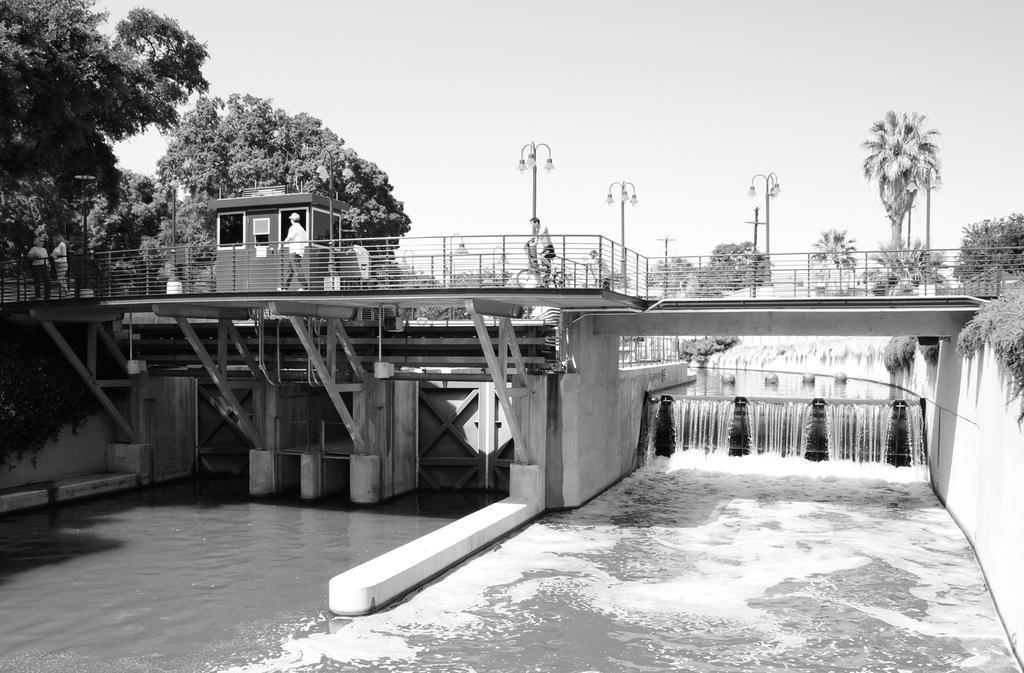Please provide a concise description of this image. This is a black and white picture. In the background we can see the sky and the trees. In this picture we can see a bridge and on the bridge we can see a shelter, people, a man is riding a bicycle. We can see the railings, light poles and other poles. We can see the waterfalls and beams under the bridge. 